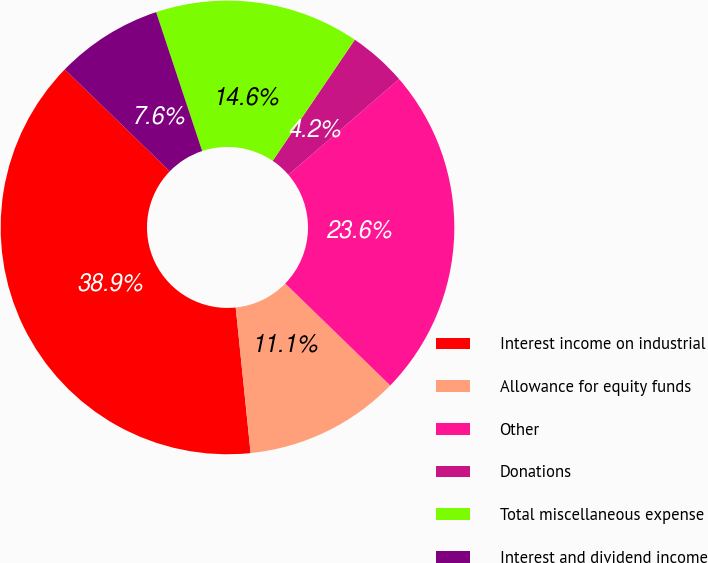Convert chart. <chart><loc_0><loc_0><loc_500><loc_500><pie_chart><fcel>Interest income on industrial<fcel>Allowance for equity funds<fcel>Other<fcel>Donations<fcel>Total miscellaneous expense<fcel>Interest and dividend income<nl><fcel>38.89%<fcel>11.11%<fcel>23.61%<fcel>4.17%<fcel>14.58%<fcel>7.64%<nl></chart> 